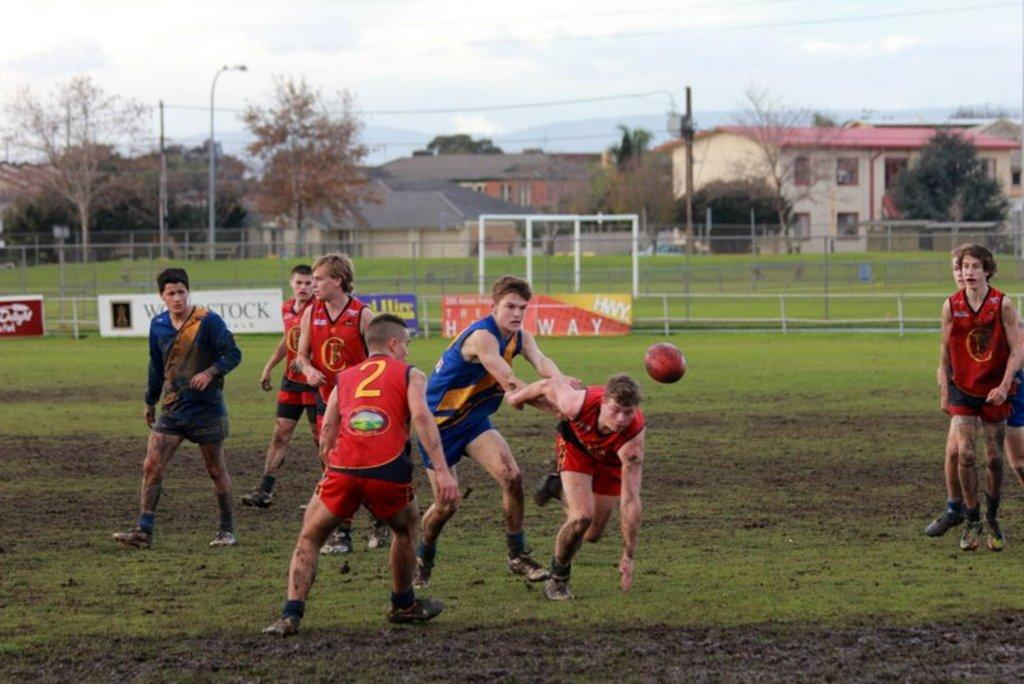<image>
Describe the image concisely. Player number 2 crouches in preparation for going after the ball. 